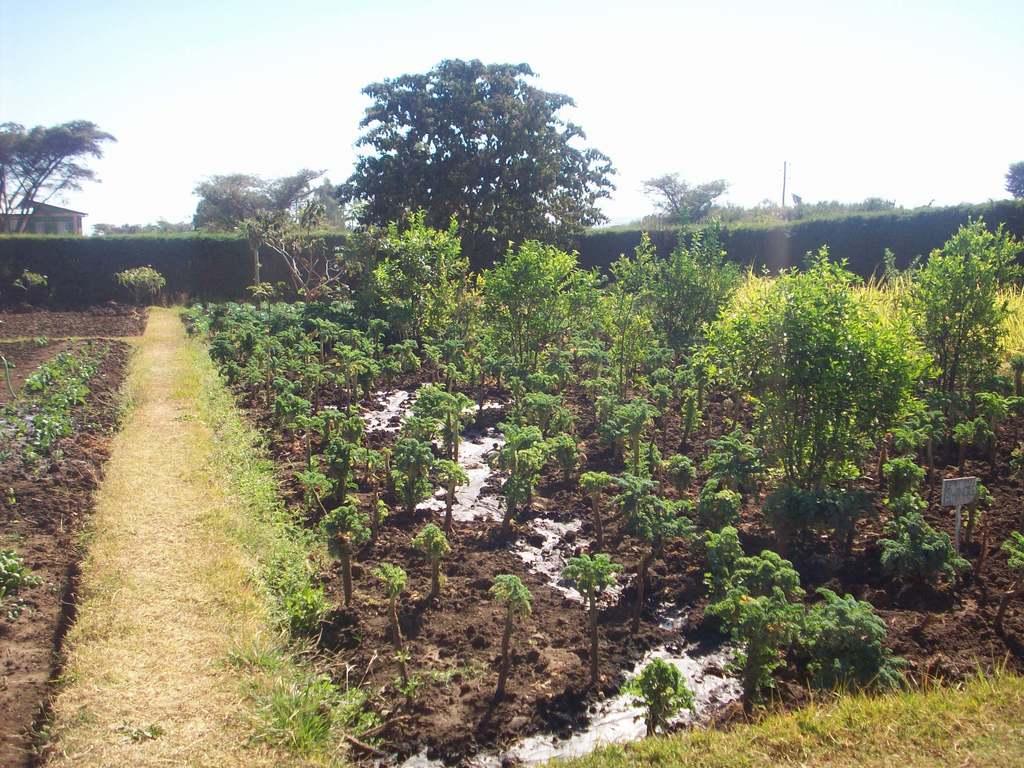How would you summarize this image in a sentence or two? In the center of the image there are plants. There is grass. In the background of the image there are trees. At the top of the image there is sky. 